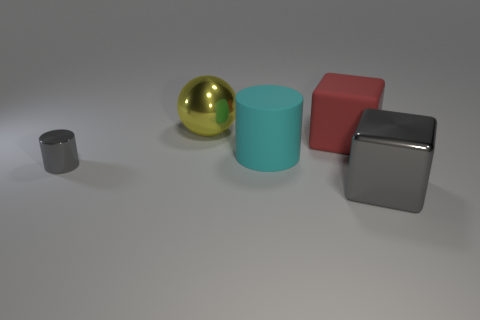Add 1 gray spheres. How many objects exist? 6 Subtract all balls. How many objects are left? 4 Subtract all big cyan things. Subtract all big cyan rubber things. How many objects are left? 3 Add 4 gray metallic cubes. How many gray metallic cubes are left? 5 Add 3 cyan rubber objects. How many cyan rubber objects exist? 4 Subtract 0 blue spheres. How many objects are left? 5 